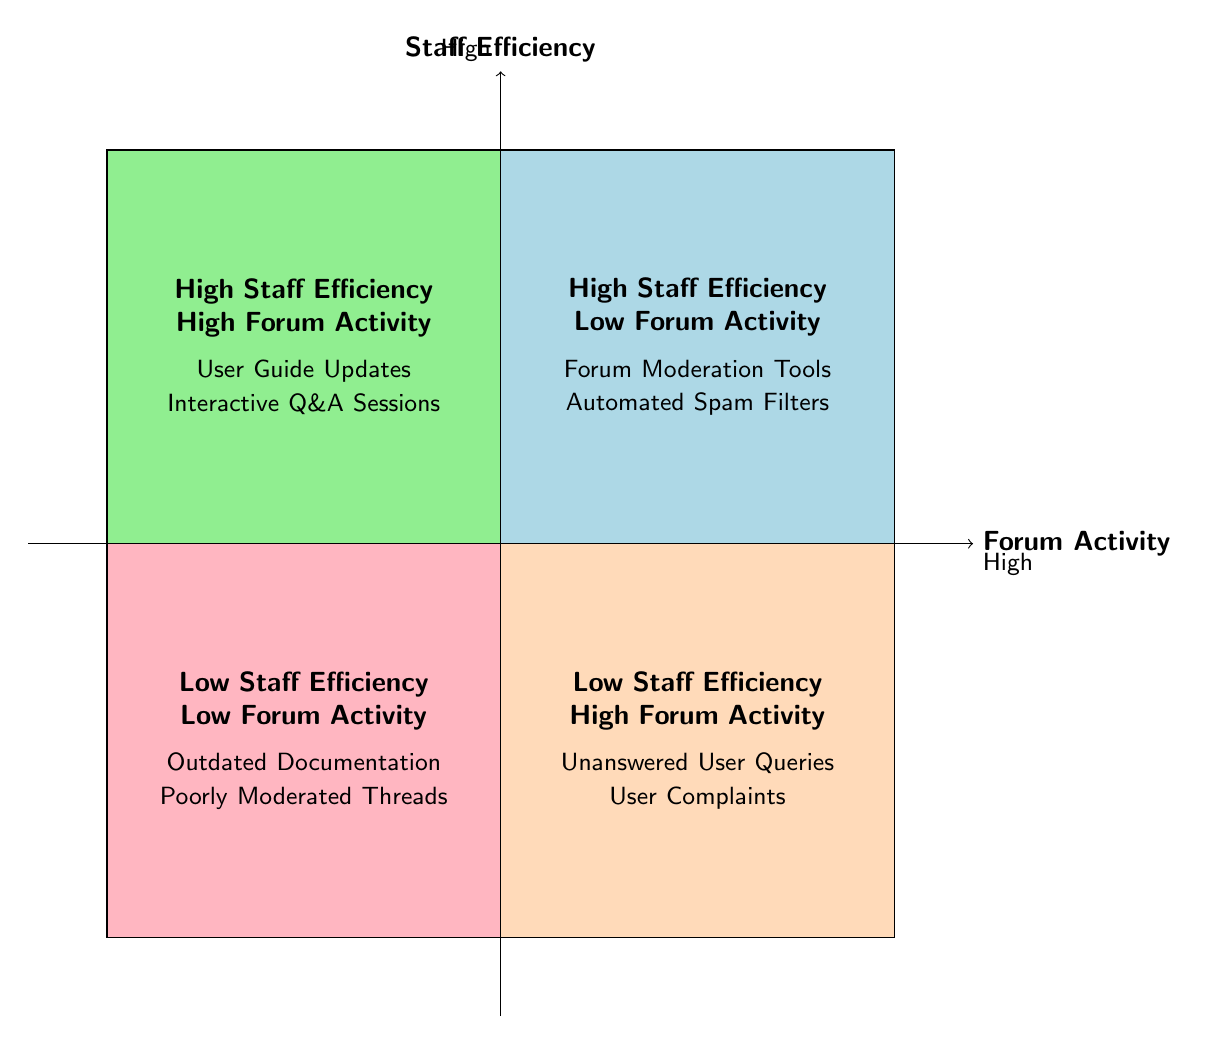What are the examples listed in the "High Staff Efficiency / Low Forum Activity" quadrant? The "High Staff Efficiency / Low Forum Activity" quadrant lists "Forum Moderation Tools" and "Automated Spam Filters" as examples.
Answer: Forum Moderation Tools, Automated Spam Filters What is the activity level in the "Low Staff Efficiency / High Forum Activity" quadrant? This quadrant describes a situation where staff efficiency is low, but user engagement is high, indicating an activity level of "High."
Answer: High How many quadrants are presented in the diagram? The diagram features four quadrants, each corresponding to different combinations of staff efficiency and forum activity levels.
Answer: Four What is the relationship between "User Guide Updates" and staff efficiency? "User Guide Updates" appear in the "High Staff Efficiency / High Forum Activity" quadrant, indicating that they are associated with high efficiency in staff performance.
Answer: High Which example is associated with low activity and low efficiency? In the "Low Staff Efficiency / Low Forum Activity" quadrant, "Outdated Documentation" is explicitly mentioned as an example that corresponds to both low staff efficiency and low forum activity.
Answer: Outdated Documentation What describes the scenario in the "Low Staff Efficiency / Low Forum Activity" quadrant? This quadrant combines low staff efficiency with low forum activity, indicating an overall ineffectiveness in both user engagement and staff performance.
Answer: Inefficient staff and low user engagement Which quadrant indicates both high staff efficiency and high forum activity? The quadrant labeled "High Staff Efficiency / High Forum Activity" corresponds to situations where both staff and user engagement are performing well.
Answer: High Staff Efficiency / High Forum Activity In which quadrant are "Unanswered User Queries" found? "Unanswered User Queries" is an example included in the "Low Staff Efficiency / High Forum Activity" quadrant, highlighting inefficiency despite high user engagement.
Answer: Low Staff Efficiency / High Forum Activity 